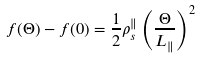<formula> <loc_0><loc_0><loc_500><loc_500>f ( \Theta ) - f ( 0 ) = \frac { 1 } { 2 } \rho _ { s } ^ { \| } \left ( \frac { \Theta } { L _ { \| } } \right ) ^ { 2 }</formula> 